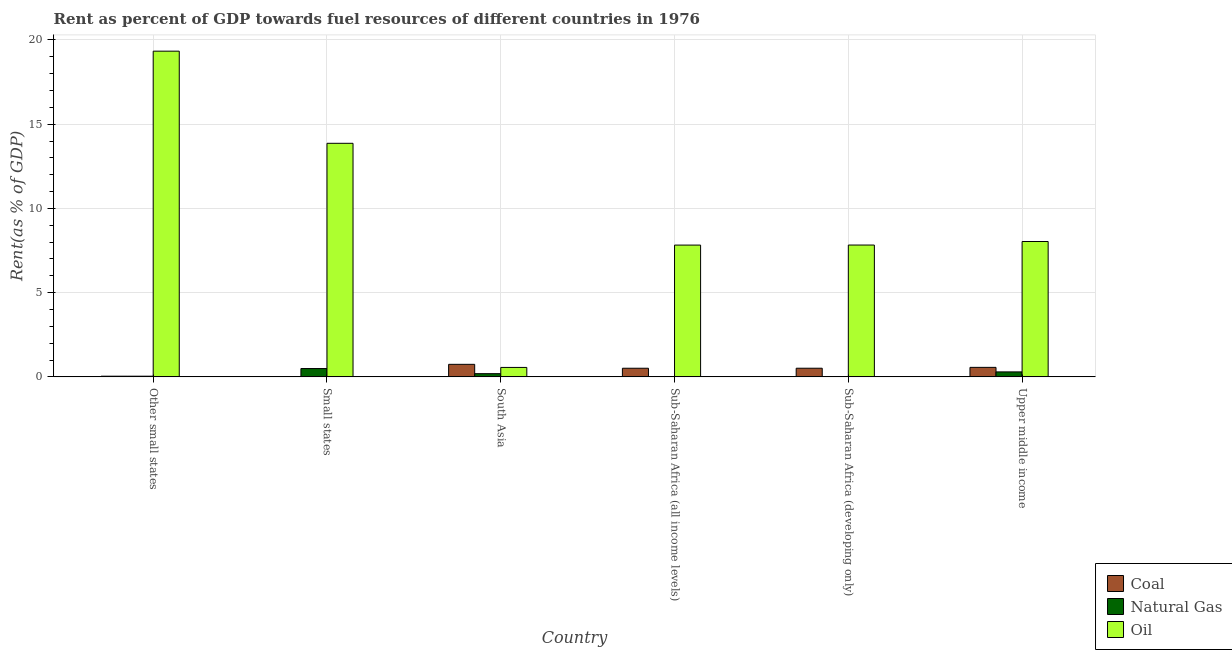How many different coloured bars are there?
Offer a very short reply. 3. How many groups of bars are there?
Offer a terse response. 6. Are the number of bars per tick equal to the number of legend labels?
Your answer should be very brief. Yes. Are the number of bars on each tick of the X-axis equal?
Keep it short and to the point. Yes. How many bars are there on the 6th tick from the left?
Ensure brevity in your answer.  3. What is the label of the 1st group of bars from the left?
Provide a short and direct response. Other small states. What is the rent towards coal in Sub-Saharan Africa (all income levels)?
Offer a terse response. 0.51. Across all countries, what is the maximum rent towards coal?
Your response must be concise. 0.74. Across all countries, what is the minimum rent towards coal?
Provide a short and direct response. 0.02. In which country was the rent towards natural gas minimum?
Your answer should be compact. Sub-Saharan Africa (all income levels). What is the total rent towards natural gas in the graph?
Your response must be concise. 1.06. What is the difference between the rent towards natural gas in Small states and that in South Asia?
Your answer should be compact. 0.3. What is the difference between the rent towards coal in Sub-Saharan Africa (developing only) and the rent towards oil in Upper middle income?
Your answer should be very brief. -7.52. What is the average rent towards coal per country?
Offer a terse response. 0.4. What is the difference between the rent towards oil and rent towards coal in Small states?
Your answer should be compact. 13.85. What is the ratio of the rent towards natural gas in Small states to that in Sub-Saharan Africa (all income levels)?
Keep it short and to the point. 22.58. What is the difference between the highest and the second highest rent towards oil?
Keep it short and to the point. 5.47. What is the difference between the highest and the lowest rent towards natural gas?
Make the answer very short. 0.47. In how many countries, is the rent towards coal greater than the average rent towards coal taken over all countries?
Provide a succinct answer. 4. Is the sum of the rent towards oil in Sub-Saharan Africa (developing only) and Upper middle income greater than the maximum rent towards natural gas across all countries?
Provide a succinct answer. Yes. What does the 1st bar from the left in Small states represents?
Offer a terse response. Coal. What does the 3rd bar from the right in Other small states represents?
Your answer should be compact. Coal. What is the difference between two consecutive major ticks on the Y-axis?
Provide a succinct answer. 5. Does the graph contain any zero values?
Keep it short and to the point. No. Where does the legend appear in the graph?
Keep it short and to the point. Bottom right. How are the legend labels stacked?
Your answer should be very brief. Vertical. What is the title of the graph?
Offer a very short reply. Rent as percent of GDP towards fuel resources of different countries in 1976. Does "Coal sources" appear as one of the legend labels in the graph?
Your answer should be very brief. No. What is the label or title of the X-axis?
Offer a terse response. Country. What is the label or title of the Y-axis?
Ensure brevity in your answer.  Rent(as % of GDP). What is the Rent(as % of GDP) of Coal in Other small states?
Your answer should be compact. 0.04. What is the Rent(as % of GDP) in Natural Gas in Other small states?
Your answer should be very brief. 0.04. What is the Rent(as % of GDP) of Oil in Other small states?
Offer a terse response. 19.33. What is the Rent(as % of GDP) of Coal in Small states?
Your answer should be very brief. 0.02. What is the Rent(as % of GDP) of Natural Gas in Small states?
Provide a succinct answer. 0.49. What is the Rent(as % of GDP) of Oil in Small states?
Your response must be concise. 13.86. What is the Rent(as % of GDP) in Coal in South Asia?
Make the answer very short. 0.74. What is the Rent(as % of GDP) of Natural Gas in South Asia?
Provide a short and direct response. 0.19. What is the Rent(as % of GDP) in Oil in South Asia?
Ensure brevity in your answer.  0.56. What is the Rent(as % of GDP) of Coal in Sub-Saharan Africa (all income levels)?
Make the answer very short. 0.51. What is the Rent(as % of GDP) in Natural Gas in Sub-Saharan Africa (all income levels)?
Keep it short and to the point. 0.02. What is the Rent(as % of GDP) of Oil in Sub-Saharan Africa (all income levels)?
Offer a very short reply. 7.82. What is the Rent(as % of GDP) of Coal in Sub-Saharan Africa (developing only)?
Provide a succinct answer. 0.51. What is the Rent(as % of GDP) in Natural Gas in Sub-Saharan Africa (developing only)?
Your answer should be very brief. 0.02. What is the Rent(as % of GDP) in Oil in Sub-Saharan Africa (developing only)?
Your response must be concise. 7.83. What is the Rent(as % of GDP) of Coal in Upper middle income?
Offer a terse response. 0.56. What is the Rent(as % of GDP) of Natural Gas in Upper middle income?
Your response must be concise. 0.3. What is the Rent(as % of GDP) in Oil in Upper middle income?
Offer a very short reply. 8.03. Across all countries, what is the maximum Rent(as % of GDP) in Coal?
Keep it short and to the point. 0.74. Across all countries, what is the maximum Rent(as % of GDP) in Natural Gas?
Keep it short and to the point. 0.49. Across all countries, what is the maximum Rent(as % of GDP) of Oil?
Make the answer very short. 19.33. Across all countries, what is the minimum Rent(as % of GDP) of Coal?
Keep it short and to the point. 0.02. Across all countries, what is the minimum Rent(as % of GDP) in Natural Gas?
Ensure brevity in your answer.  0.02. Across all countries, what is the minimum Rent(as % of GDP) in Oil?
Keep it short and to the point. 0.56. What is the total Rent(as % of GDP) of Coal in the graph?
Make the answer very short. 2.39. What is the total Rent(as % of GDP) in Natural Gas in the graph?
Keep it short and to the point. 1.06. What is the total Rent(as % of GDP) in Oil in the graph?
Offer a terse response. 57.44. What is the difference between the Rent(as % of GDP) of Coal in Other small states and that in Small states?
Give a very brief answer. 0.03. What is the difference between the Rent(as % of GDP) in Natural Gas in Other small states and that in Small states?
Provide a succinct answer. -0.45. What is the difference between the Rent(as % of GDP) of Oil in Other small states and that in Small states?
Offer a very short reply. 5.47. What is the difference between the Rent(as % of GDP) in Coal in Other small states and that in South Asia?
Provide a succinct answer. -0.7. What is the difference between the Rent(as % of GDP) of Oil in Other small states and that in South Asia?
Offer a very short reply. 18.77. What is the difference between the Rent(as % of GDP) of Coal in Other small states and that in Sub-Saharan Africa (all income levels)?
Offer a very short reply. -0.47. What is the difference between the Rent(as % of GDP) of Natural Gas in Other small states and that in Sub-Saharan Africa (all income levels)?
Keep it short and to the point. 0.02. What is the difference between the Rent(as % of GDP) in Oil in Other small states and that in Sub-Saharan Africa (all income levels)?
Offer a very short reply. 11.51. What is the difference between the Rent(as % of GDP) in Coal in Other small states and that in Sub-Saharan Africa (developing only)?
Your answer should be compact. -0.47. What is the difference between the Rent(as % of GDP) in Natural Gas in Other small states and that in Sub-Saharan Africa (developing only)?
Offer a terse response. 0.02. What is the difference between the Rent(as % of GDP) of Oil in Other small states and that in Sub-Saharan Africa (developing only)?
Your answer should be very brief. 11.51. What is the difference between the Rent(as % of GDP) in Coal in Other small states and that in Upper middle income?
Provide a succinct answer. -0.52. What is the difference between the Rent(as % of GDP) of Natural Gas in Other small states and that in Upper middle income?
Keep it short and to the point. -0.25. What is the difference between the Rent(as % of GDP) in Oil in Other small states and that in Upper middle income?
Give a very brief answer. 11.3. What is the difference between the Rent(as % of GDP) in Coal in Small states and that in South Asia?
Ensure brevity in your answer.  -0.73. What is the difference between the Rent(as % of GDP) in Natural Gas in Small states and that in South Asia?
Ensure brevity in your answer.  0.3. What is the difference between the Rent(as % of GDP) of Oil in Small states and that in South Asia?
Keep it short and to the point. 13.3. What is the difference between the Rent(as % of GDP) of Coal in Small states and that in Sub-Saharan Africa (all income levels)?
Offer a terse response. -0.5. What is the difference between the Rent(as % of GDP) of Natural Gas in Small states and that in Sub-Saharan Africa (all income levels)?
Your answer should be compact. 0.47. What is the difference between the Rent(as % of GDP) in Oil in Small states and that in Sub-Saharan Africa (all income levels)?
Provide a short and direct response. 6.04. What is the difference between the Rent(as % of GDP) in Coal in Small states and that in Sub-Saharan Africa (developing only)?
Your answer should be compact. -0.5. What is the difference between the Rent(as % of GDP) in Natural Gas in Small states and that in Sub-Saharan Africa (developing only)?
Give a very brief answer. 0.47. What is the difference between the Rent(as % of GDP) in Oil in Small states and that in Sub-Saharan Africa (developing only)?
Make the answer very short. 6.04. What is the difference between the Rent(as % of GDP) in Coal in Small states and that in Upper middle income?
Keep it short and to the point. -0.55. What is the difference between the Rent(as % of GDP) in Natural Gas in Small states and that in Upper middle income?
Ensure brevity in your answer.  0.2. What is the difference between the Rent(as % of GDP) in Oil in Small states and that in Upper middle income?
Provide a succinct answer. 5.83. What is the difference between the Rent(as % of GDP) in Coal in South Asia and that in Sub-Saharan Africa (all income levels)?
Keep it short and to the point. 0.23. What is the difference between the Rent(as % of GDP) of Natural Gas in South Asia and that in Sub-Saharan Africa (all income levels)?
Ensure brevity in your answer.  0.17. What is the difference between the Rent(as % of GDP) in Oil in South Asia and that in Sub-Saharan Africa (all income levels)?
Your answer should be compact. -7.26. What is the difference between the Rent(as % of GDP) in Coal in South Asia and that in Sub-Saharan Africa (developing only)?
Give a very brief answer. 0.23. What is the difference between the Rent(as % of GDP) in Natural Gas in South Asia and that in Sub-Saharan Africa (developing only)?
Your answer should be compact. 0.17. What is the difference between the Rent(as % of GDP) in Oil in South Asia and that in Sub-Saharan Africa (developing only)?
Ensure brevity in your answer.  -7.26. What is the difference between the Rent(as % of GDP) in Coal in South Asia and that in Upper middle income?
Offer a very short reply. 0.18. What is the difference between the Rent(as % of GDP) in Natural Gas in South Asia and that in Upper middle income?
Offer a very short reply. -0.1. What is the difference between the Rent(as % of GDP) in Oil in South Asia and that in Upper middle income?
Your answer should be compact. -7.47. What is the difference between the Rent(as % of GDP) in Coal in Sub-Saharan Africa (all income levels) and that in Sub-Saharan Africa (developing only)?
Keep it short and to the point. -0. What is the difference between the Rent(as % of GDP) in Oil in Sub-Saharan Africa (all income levels) and that in Sub-Saharan Africa (developing only)?
Ensure brevity in your answer.  -0. What is the difference between the Rent(as % of GDP) of Coal in Sub-Saharan Africa (all income levels) and that in Upper middle income?
Offer a very short reply. -0.05. What is the difference between the Rent(as % of GDP) in Natural Gas in Sub-Saharan Africa (all income levels) and that in Upper middle income?
Give a very brief answer. -0.27. What is the difference between the Rent(as % of GDP) of Oil in Sub-Saharan Africa (all income levels) and that in Upper middle income?
Your answer should be very brief. -0.21. What is the difference between the Rent(as % of GDP) in Coal in Sub-Saharan Africa (developing only) and that in Upper middle income?
Your response must be concise. -0.05. What is the difference between the Rent(as % of GDP) in Natural Gas in Sub-Saharan Africa (developing only) and that in Upper middle income?
Provide a short and direct response. -0.27. What is the difference between the Rent(as % of GDP) of Oil in Sub-Saharan Africa (developing only) and that in Upper middle income?
Provide a short and direct response. -0.21. What is the difference between the Rent(as % of GDP) of Coal in Other small states and the Rent(as % of GDP) of Natural Gas in Small states?
Provide a short and direct response. -0.45. What is the difference between the Rent(as % of GDP) in Coal in Other small states and the Rent(as % of GDP) in Oil in Small states?
Your answer should be compact. -13.82. What is the difference between the Rent(as % of GDP) in Natural Gas in Other small states and the Rent(as % of GDP) in Oil in Small states?
Provide a succinct answer. -13.82. What is the difference between the Rent(as % of GDP) in Coal in Other small states and the Rent(as % of GDP) in Natural Gas in South Asia?
Make the answer very short. -0.15. What is the difference between the Rent(as % of GDP) of Coal in Other small states and the Rent(as % of GDP) of Oil in South Asia?
Provide a short and direct response. -0.52. What is the difference between the Rent(as % of GDP) of Natural Gas in Other small states and the Rent(as % of GDP) of Oil in South Asia?
Your answer should be very brief. -0.52. What is the difference between the Rent(as % of GDP) in Coal in Other small states and the Rent(as % of GDP) in Natural Gas in Sub-Saharan Africa (all income levels)?
Offer a terse response. 0.02. What is the difference between the Rent(as % of GDP) in Coal in Other small states and the Rent(as % of GDP) in Oil in Sub-Saharan Africa (all income levels)?
Ensure brevity in your answer.  -7.78. What is the difference between the Rent(as % of GDP) in Natural Gas in Other small states and the Rent(as % of GDP) in Oil in Sub-Saharan Africa (all income levels)?
Keep it short and to the point. -7.78. What is the difference between the Rent(as % of GDP) in Coal in Other small states and the Rent(as % of GDP) in Natural Gas in Sub-Saharan Africa (developing only)?
Provide a short and direct response. 0.02. What is the difference between the Rent(as % of GDP) in Coal in Other small states and the Rent(as % of GDP) in Oil in Sub-Saharan Africa (developing only)?
Give a very brief answer. -7.79. What is the difference between the Rent(as % of GDP) in Natural Gas in Other small states and the Rent(as % of GDP) in Oil in Sub-Saharan Africa (developing only)?
Your response must be concise. -7.78. What is the difference between the Rent(as % of GDP) in Coal in Other small states and the Rent(as % of GDP) in Natural Gas in Upper middle income?
Provide a short and direct response. -0.26. What is the difference between the Rent(as % of GDP) in Coal in Other small states and the Rent(as % of GDP) in Oil in Upper middle income?
Provide a short and direct response. -7.99. What is the difference between the Rent(as % of GDP) of Natural Gas in Other small states and the Rent(as % of GDP) of Oil in Upper middle income?
Keep it short and to the point. -7.99. What is the difference between the Rent(as % of GDP) of Coal in Small states and the Rent(as % of GDP) of Natural Gas in South Asia?
Offer a terse response. -0.18. What is the difference between the Rent(as % of GDP) of Coal in Small states and the Rent(as % of GDP) of Oil in South Asia?
Ensure brevity in your answer.  -0.55. What is the difference between the Rent(as % of GDP) of Natural Gas in Small states and the Rent(as % of GDP) of Oil in South Asia?
Your response must be concise. -0.07. What is the difference between the Rent(as % of GDP) of Coal in Small states and the Rent(as % of GDP) of Natural Gas in Sub-Saharan Africa (all income levels)?
Keep it short and to the point. -0.01. What is the difference between the Rent(as % of GDP) of Coal in Small states and the Rent(as % of GDP) of Oil in Sub-Saharan Africa (all income levels)?
Your response must be concise. -7.81. What is the difference between the Rent(as % of GDP) in Natural Gas in Small states and the Rent(as % of GDP) in Oil in Sub-Saharan Africa (all income levels)?
Your answer should be compact. -7.33. What is the difference between the Rent(as % of GDP) of Coal in Small states and the Rent(as % of GDP) of Natural Gas in Sub-Saharan Africa (developing only)?
Provide a succinct answer. -0.01. What is the difference between the Rent(as % of GDP) of Coal in Small states and the Rent(as % of GDP) of Oil in Sub-Saharan Africa (developing only)?
Your answer should be very brief. -7.81. What is the difference between the Rent(as % of GDP) of Natural Gas in Small states and the Rent(as % of GDP) of Oil in Sub-Saharan Africa (developing only)?
Make the answer very short. -7.33. What is the difference between the Rent(as % of GDP) in Coal in Small states and the Rent(as % of GDP) in Natural Gas in Upper middle income?
Ensure brevity in your answer.  -0.28. What is the difference between the Rent(as % of GDP) in Coal in Small states and the Rent(as % of GDP) in Oil in Upper middle income?
Keep it short and to the point. -8.02. What is the difference between the Rent(as % of GDP) of Natural Gas in Small states and the Rent(as % of GDP) of Oil in Upper middle income?
Offer a terse response. -7.54. What is the difference between the Rent(as % of GDP) in Coal in South Asia and the Rent(as % of GDP) in Natural Gas in Sub-Saharan Africa (all income levels)?
Give a very brief answer. 0.72. What is the difference between the Rent(as % of GDP) of Coal in South Asia and the Rent(as % of GDP) of Oil in Sub-Saharan Africa (all income levels)?
Keep it short and to the point. -7.08. What is the difference between the Rent(as % of GDP) in Natural Gas in South Asia and the Rent(as % of GDP) in Oil in Sub-Saharan Africa (all income levels)?
Give a very brief answer. -7.63. What is the difference between the Rent(as % of GDP) of Coal in South Asia and the Rent(as % of GDP) of Natural Gas in Sub-Saharan Africa (developing only)?
Give a very brief answer. 0.72. What is the difference between the Rent(as % of GDP) in Coal in South Asia and the Rent(as % of GDP) in Oil in Sub-Saharan Africa (developing only)?
Provide a succinct answer. -7.08. What is the difference between the Rent(as % of GDP) in Natural Gas in South Asia and the Rent(as % of GDP) in Oil in Sub-Saharan Africa (developing only)?
Ensure brevity in your answer.  -7.63. What is the difference between the Rent(as % of GDP) in Coal in South Asia and the Rent(as % of GDP) in Natural Gas in Upper middle income?
Make the answer very short. 0.45. What is the difference between the Rent(as % of GDP) in Coal in South Asia and the Rent(as % of GDP) in Oil in Upper middle income?
Keep it short and to the point. -7.29. What is the difference between the Rent(as % of GDP) in Natural Gas in South Asia and the Rent(as % of GDP) in Oil in Upper middle income?
Offer a very short reply. -7.84. What is the difference between the Rent(as % of GDP) in Coal in Sub-Saharan Africa (all income levels) and the Rent(as % of GDP) in Natural Gas in Sub-Saharan Africa (developing only)?
Make the answer very short. 0.49. What is the difference between the Rent(as % of GDP) in Coal in Sub-Saharan Africa (all income levels) and the Rent(as % of GDP) in Oil in Sub-Saharan Africa (developing only)?
Keep it short and to the point. -7.31. What is the difference between the Rent(as % of GDP) in Natural Gas in Sub-Saharan Africa (all income levels) and the Rent(as % of GDP) in Oil in Sub-Saharan Africa (developing only)?
Make the answer very short. -7.8. What is the difference between the Rent(as % of GDP) in Coal in Sub-Saharan Africa (all income levels) and the Rent(as % of GDP) in Natural Gas in Upper middle income?
Offer a terse response. 0.22. What is the difference between the Rent(as % of GDP) of Coal in Sub-Saharan Africa (all income levels) and the Rent(as % of GDP) of Oil in Upper middle income?
Offer a terse response. -7.52. What is the difference between the Rent(as % of GDP) in Natural Gas in Sub-Saharan Africa (all income levels) and the Rent(as % of GDP) in Oil in Upper middle income?
Offer a terse response. -8.01. What is the difference between the Rent(as % of GDP) of Coal in Sub-Saharan Africa (developing only) and the Rent(as % of GDP) of Natural Gas in Upper middle income?
Make the answer very short. 0.22. What is the difference between the Rent(as % of GDP) of Coal in Sub-Saharan Africa (developing only) and the Rent(as % of GDP) of Oil in Upper middle income?
Your answer should be compact. -7.52. What is the difference between the Rent(as % of GDP) in Natural Gas in Sub-Saharan Africa (developing only) and the Rent(as % of GDP) in Oil in Upper middle income?
Make the answer very short. -8.01. What is the average Rent(as % of GDP) in Coal per country?
Provide a succinct answer. 0.4. What is the average Rent(as % of GDP) of Natural Gas per country?
Your response must be concise. 0.18. What is the average Rent(as % of GDP) of Oil per country?
Your answer should be very brief. 9.57. What is the difference between the Rent(as % of GDP) of Coal and Rent(as % of GDP) of Natural Gas in Other small states?
Keep it short and to the point. -0. What is the difference between the Rent(as % of GDP) of Coal and Rent(as % of GDP) of Oil in Other small states?
Your answer should be very brief. -19.29. What is the difference between the Rent(as % of GDP) in Natural Gas and Rent(as % of GDP) in Oil in Other small states?
Provide a succinct answer. -19.29. What is the difference between the Rent(as % of GDP) in Coal and Rent(as % of GDP) in Natural Gas in Small states?
Your answer should be very brief. -0.48. What is the difference between the Rent(as % of GDP) in Coal and Rent(as % of GDP) in Oil in Small states?
Offer a terse response. -13.85. What is the difference between the Rent(as % of GDP) in Natural Gas and Rent(as % of GDP) in Oil in Small states?
Provide a short and direct response. -13.37. What is the difference between the Rent(as % of GDP) in Coal and Rent(as % of GDP) in Natural Gas in South Asia?
Your answer should be very brief. 0.55. What is the difference between the Rent(as % of GDP) of Coal and Rent(as % of GDP) of Oil in South Asia?
Offer a terse response. 0.18. What is the difference between the Rent(as % of GDP) of Natural Gas and Rent(as % of GDP) of Oil in South Asia?
Make the answer very short. -0.37. What is the difference between the Rent(as % of GDP) of Coal and Rent(as % of GDP) of Natural Gas in Sub-Saharan Africa (all income levels)?
Your answer should be compact. 0.49. What is the difference between the Rent(as % of GDP) in Coal and Rent(as % of GDP) in Oil in Sub-Saharan Africa (all income levels)?
Give a very brief answer. -7.31. What is the difference between the Rent(as % of GDP) in Natural Gas and Rent(as % of GDP) in Oil in Sub-Saharan Africa (all income levels)?
Ensure brevity in your answer.  -7.8. What is the difference between the Rent(as % of GDP) in Coal and Rent(as % of GDP) in Natural Gas in Sub-Saharan Africa (developing only)?
Offer a terse response. 0.49. What is the difference between the Rent(as % of GDP) of Coal and Rent(as % of GDP) of Oil in Sub-Saharan Africa (developing only)?
Your response must be concise. -7.31. What is the difference between the Rent(as % of GDP) of Natural Gas and Rent(as % of GDP) of Oil in Sub-Saharan Africa (developing only)?
Keep it short and to the point. -7.8. What is the difference between the Rent(as % of GDP) in Coal and Rent(as % of GDP) in Natural Gas in Upper middle income?
Your answer should be very brief. 0.27. What is the difference between the Rent(as % of GDP) of Coal and Rent(as % of GDP) of Oil in Upper middle income?
Provide a succinct answer. -7.47. What is the difference between the Rent(as % of GDP) in Natural Gas and Rent(as % of GDP) in Oil in Upper middle income?
Your answer should be very brief. -7.74. What is the ratio of the Rent(as % of GDP) of Coal in Other small states to that in Small states?
Keep it short and to the point. 2.65. What is the ratio of the Rent(as % of GDP) of Natural Gas in Other small states to that in Small states?
Your answer should be very brief. 0.08. What is the ratio of the Rent(as % of GDP) in Oil in Other small states to that in Small states?
Give a very brief answer. 1.39. What is the ratio of the Rent(as % of GDP) in Coal in Other small states to that in South Asia?
Your answer should be compact. 0.05. What is the ratio of the Rent(as % of GDP) in Natural Gas in Other small states to that in South Asia?
Provide a short and direct response. 0.21. What is the ratio of the Rent(as % of GDP) of Oil in Other small states to that in South Asia?
Keep it short and to the point. 34.48. What is the ratio of the Rent(as % of GDP) in Coal in Other small states to that in Sub-Saharan Africa (all income levels)?
Offer a very short reply. 0.08. What is the ratio of the Rent(as % of GDP) in Natural Gas in Other small states to that in Sub-Saharan Africa (all income levels)?
Provide a succinct answer. 1.85. What is the ratio of the Rent(as % of GDP) in Oil in Other small states to that in Sub-Saharan Africa (all income levels)?
Provide a succinct answer. 2.47. What is the ratio of the Rent(as % of GDP) in Coal in Other small states to that in Sub-Saharan Africa (developing only)?
Provide a succinct answer. 0.08. What is the ratio of the Rent(as % of GDP) of Natural Gas in Other small states to that in Sub-Saharan Africa (developing only)?
Offer a very short reply. 1.85. What is the ratio of the Rent(as % of GDP) in Oil in Other small states to that in Sub-Saharan Africa (developing only)?
Make the answer very short. 2.47. What is the ratio of the Rent(as % of GDP) in Coal in Other small states to that in Upper middle income?
Provide a short and direct response. 0.07. What is the ratio of the Rent(as % of GDP) of Natural Gas in Other small states to that in Upper middle income?
Your answer should be very brief. 0.14. What is the ratio of the Rent(as % of GDP) of Oil in Other small states to that in Upper middle income?
Ensure brevity in your answer.  2.41. What is the ratio of the Rent(as % of GDP) of Coal in Small states to that in South Asia?
Provide a succinct answer. 0.02. What is the ratio of the Rent(as % of GDP) in Natural Gas in Small states to that in South Asia?
Your answer should be compact. 2.6. What is the ratio of the Rent(as % of GDP) of Oil in Small states to that in South Asia?
Keep it short and to the point. 24.73. What is the ratio of the Rent(as % of GDP) of Coal in Small states to that in Sub-Saharan Africa (all income levels)?
Offer a terse response. 0.03. What is the ratio of the Rent(as % of GDP) in Natural Gas in Small states to that in Sub-Saharan Africa (all income levels)?
Give a very brief answer. 22.58. What is the ratio of the Rent(as % of GDP) in Oil in Small states to that in Sub-Saharan Africa (all income levels)?
Your response must be concise. 1.77. What is the ratio of the Rent(as % of GDP) of Coal in Small states to that in Sub-Saharan Africa (developing only)?
Offer a very short reply. 0.03. What is the ratio of the Rent(as % of GDP) of Natural Gas in Small states to that in Sub-Saharan Africa (developing only)?
Offer a terse response. 22.55. What is the ratio of the Rent(as % of GDP) of Oil in Small states to that in Sub-Saharan Africa (developing only)?
Provide a succinct answer. 1.77. What is the ratio of the Rent(as % of GDP) of Coal in Small states to that in Upper middle income?
Your response must be concise. 0.03. What is the ratio of the Rent(as % of GDP) in Natural Gas in Small states to that in Upper middle income?
Your response must be concise. 1.67. What is the ratio of the Rent(as % of GDP) of Oil in Small states to that in Upper middle income?
Your response must be concise. 1.73. What is the ratio of the Rent(as % of GDP) in Coal in South Asia to that in Sub-Saharan Africa (all income levels)?
Your answer should be very brief. 1.45. What is the ratio of the Rent(as % of GDP) of Natural Gas in South Asia to that in Sub-Saharan Africa (all income levels)?
Offer a terse response. 8.7. What is the ratio of the Rent(as % of GDP) in Oil in South Asia to that in Sub-Saharan Africa (all income levels)?
Provide a short and direct response. 0.07. What is the ratio of the Rent(as % of GDP) of Coal in South Asia to that in Sub-Saharan Africa (developing only)?
Give a very brief answer. 1.45. What is the ratio of the Rent(as % of GDP) in Natural Gas in South Asia to that in Sub-Saharan Africa (developing only)?
Provide a succinct answer. 8.69. What is the ratio of the Rent(as % of GDP) in Oil in South Asia to that in Sub-Saharan Africa (developing only)?
Make the answer very short. 0.07. What is the ratio of the Rent(as % of GDP) in Coal in South Asia to that in Upper middle income?
Your answer should be compact. 1.32. What is the ratio of the Rent(as % of GDP) of Natural Gas in South Asia to that in Upper middle income?
Your answer should be compact. 0.65. What is the ratio of the Rent(as % of GDP) of Oil in South Asia to that in Upper middle income?
Offer a terse response. 0.07. What is the ratio of the Rent(as % of GDP) of Oil in Sub-Saharan Africa (all income levels) to that in Sub-Saharan Africa (developing only)?
Offer a terse response. 1. What is the ratio of the Rent(as % of GDP) of Coal in Sub-Saharan Africa (all income levels) to that in Upper middle income?
Offer a very short reply. 0.91. What is the ratio of the Rent(as % of GDP) in Natural Gas in Sub-Saharan Africa (all income levels) to that in Upper middle income?
Your answer should be compact. 0.07. What is the ratio of the Rent(as % of GDP) in Oil in Sub-Saharan Africa (all income levels) to that in Upper middle income?
Your answer should be compact. 0.97. What is the ratio of the Rent(as % of GDP) in Coal in Sub-Saharan Africa (developing only) to that in Upper middle income?
Offer a very short reply. 0.91. What is the ratio of the Rent(as % of GDP) of Natural Gas in Sub-Saharan Africa (developing only) to that in Upper middle income?
Ensure brevity in your answer.  0.07. What is the ratio of the Rent(as % of GDP) of Oil in Sub-Saharan Africa (developing only) to that in Upper middle income?
Your response must be concise. 0.97. What is the difference between the highest and the second highest Rent(as % of GDP) of Coal?
Your answer should be compact. 0.18. What is the difference between the highest and the second highest Rent(as % of GDP) in Natural Gas?
Your answer should be very brief. 0.2. What is the difference between the highest and the second highest Rent(as % of GDP) in Oil?
Your answer should be very brief. 5.47. What is the difference between the highest and the lowest Rent(as % of GDP) in Coal?
Ensure brevity in your answer.  0.73. What is the difference between the highest and the lowest Rent(as % of GDP) in Natural Gas?
Your answer should be very brief. 0.47. What is the difference between the highest and the lowest Rent(as % of GDP) in Oil?
Keep it short and to the point. 18.77. 